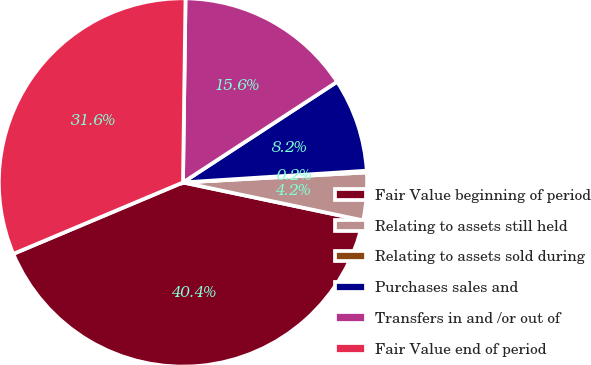Convert chart. <chart><loc_0><loc_0><loc_500><loc_500><pie_chart><fcel>Fair Value beginning of period<fcel>Relating to assets still held<fcel>Relating to assets sold during<fcel>Purchases sales and<fcel>Transfers in and /or out of<fcel>Fair Value end of period<nl><fcel>40.35%<fcel>4.17%<fcel>0.15%<fcel>8.19%<fcel>15.57%<fcel>31.56%<nl></chart> 